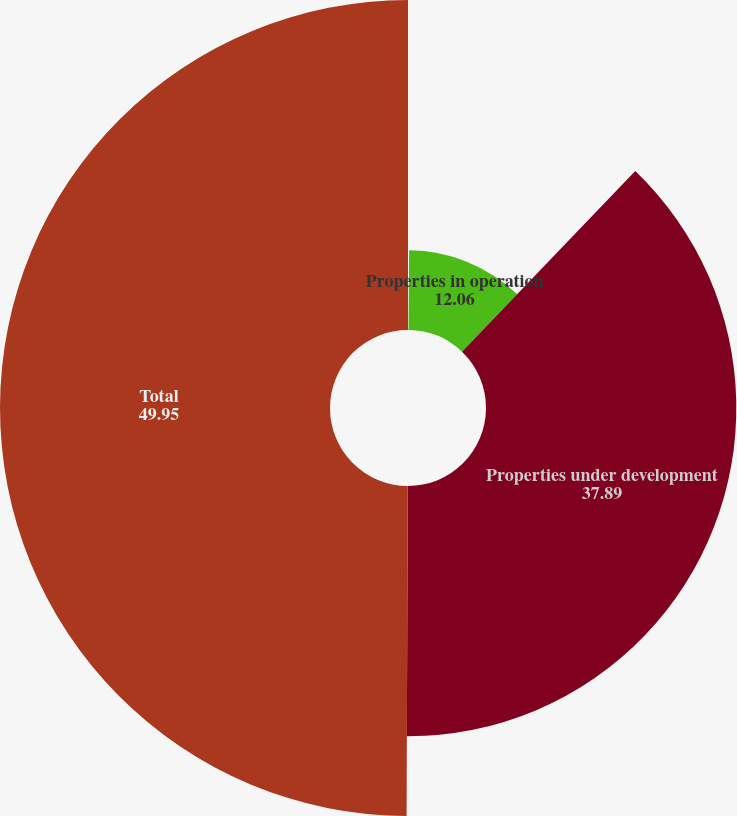<chart> <loc_0><loc_0><loc_500><loc_500><pie_chart><fcel>(In thousands)<fcel>Properties in operation<fcel>Properties under development<fcel>Total<nl><fcel>0.11%<fcel>12.06%<fcel>37.89%<fcel>49.95%<nl></chart> 